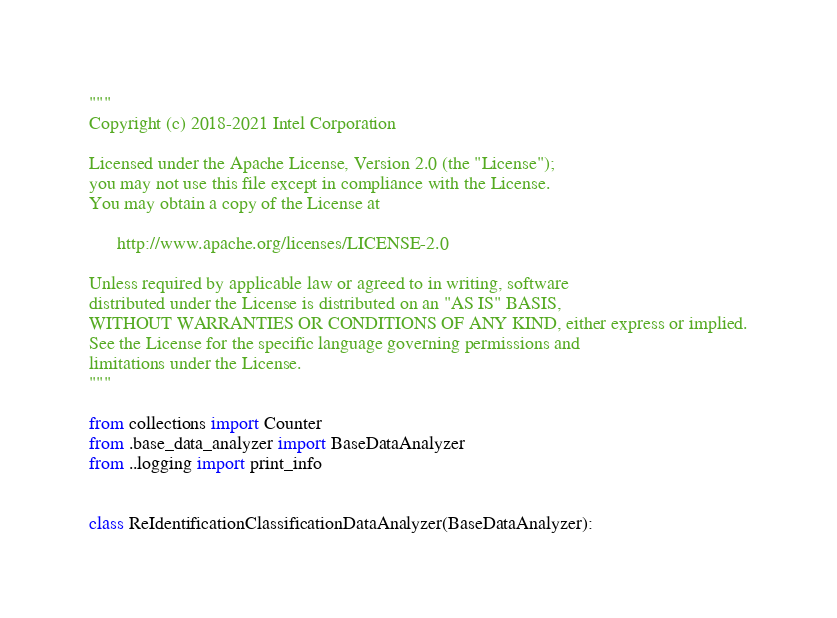<code> <loc_0><loc_0><loc_500><loc_500><_Python_>"""
Copyright (c) 2018-2021 Intel Corporation

Licensed under the Apache License, Version 2.0 (the "License");
you may not use this file except in compliance with the License.
You may obtain a copy of the License at

      http://www.apache.org/licenses/LICENSE-2.0

Unless required by applicable law or agreed to in writing, software
distributed under the License is distributed on an "AS IS" BASIS,
WITHOUT WARRANTIES OR CONDITIONS OF ANY KIND, either express or implied.
See the License for the specific language governing permissions and
limitations under the License.
"""

from collections import Counter
from .base_data_analyzer import BaseDataAnalyzer
from ..logging import print_info


class ReIdentificationClassificationDataAnalyzer(BaseDataAnalyzer):</code> 